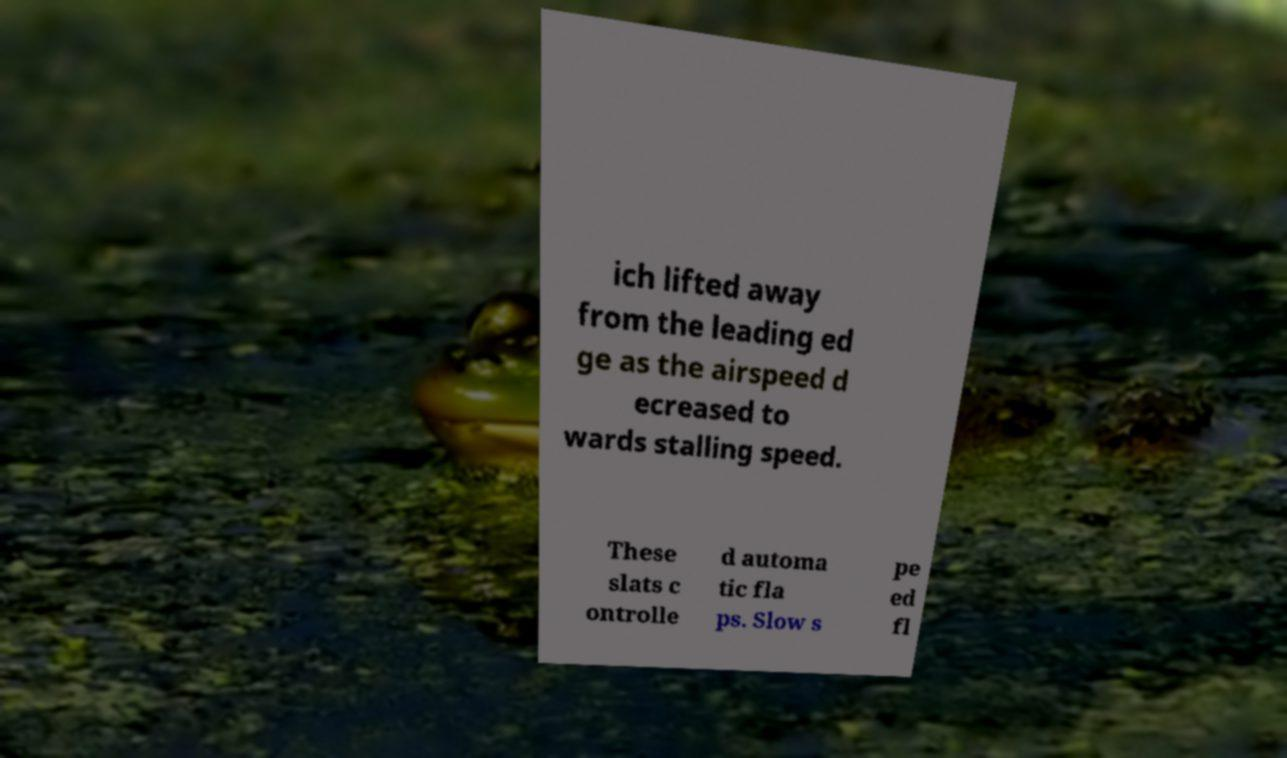Can you accurately transcribe the text from the provided image for me? ich lifted away from the leading ed ge as the airspeed d ecreased to wards stalling speed. These slats c ontrolle d automa tic fla ps. Slow s pe ed fl 